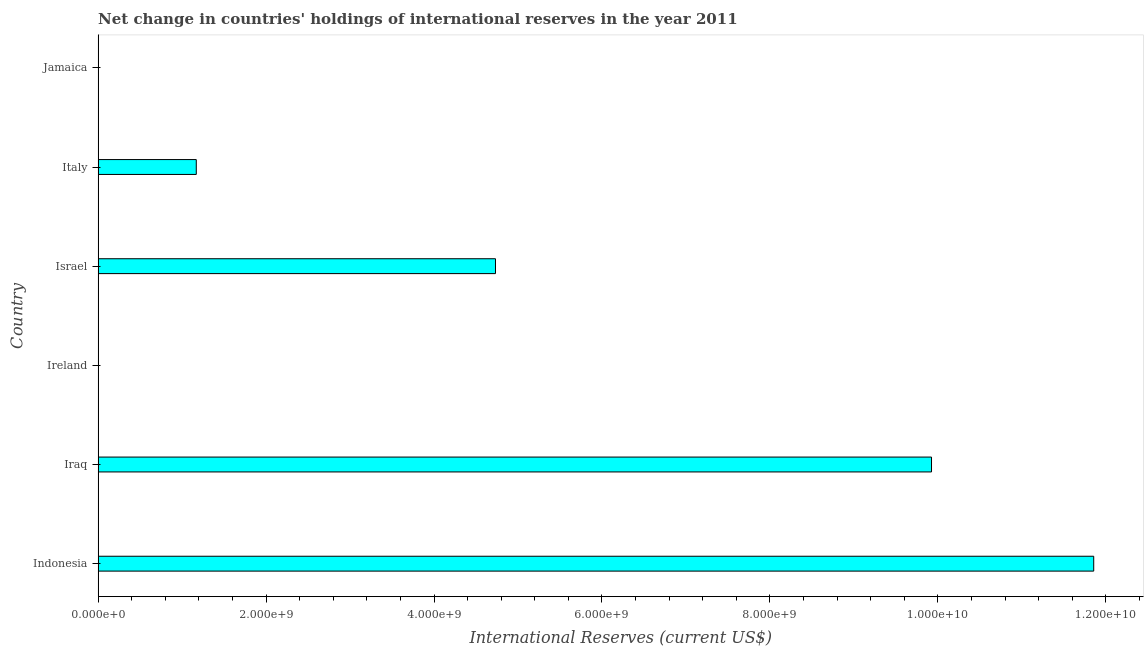Does the graph contain any zero values?
Make the answer very short. Yes. Does the graph contain grids?
Provide a succinct answer. No. What is the title of the graph?
Your answer should be very brief. Net change in countries' holdings of international reserves in the year 2011. What is the label or title of the X-axis?
Your answer should be very brief. International Reserves (current US$). What is the reserves and related items in Israel?
Your response must be concise. 4.73e+09. Across all countries, what is the maximum reserves and related items?
Provide a short and direct response. 1.19e+1. Across all countries, what is the minimum reserves and related items?
Your response must be concise. 0. In which country was the reserves and related items maximum?
Your answer should be very brief. Indonesia. What is the sum of the reserves and related items?
Your answer should be compact. 2.77e+1. What is the difference between the reserves and related items in Indonesia and Italy?
Make the answer very short. 1.07e+1. What is the average reserves and related items per country?
Offer a very short reply. 4.61e+09. What is the median reserves and related items?
Ensure brevity in your answer.  2.95e+09. What is the ratio of the reserves and related items in Indonesia to that in Italy?
Keep it short and to the point. 10.14. Is the reserves and related items in Iraq less than that in Israel?
Ensure brevity in your answer.  No. Is the difference between the reserves and related items in Iraq and Italy greater than the difference between any two countries?
Provide a short and direct response. No. What is the difference between the highest and the second highest reserves and related items?
Give a very brief answer. 1.93e+09. Is the sum of the reserves and related items in Indonesia and Israel greater than the maximum reserves and related items across all countries?
Ensure brevity in your answer.  Yes. What is the difference between the highest and the lowest reserves and related items?
Provide a succinct answer. 1.19e+1. Are all the bars in the graph horizontal?
Your answer should be very brief. Yes. How many countries are there in the graph?
Provide a short and direct response. 6. What is the difference between two consecutive major ticks on the X-axis?
Provide a succinct answer. 2.00e+09. Are the values on the major ticks of X-axis written in scientific E-notation?
Your answer should be compact. Yes. What is the International Reserves (current US$) in Indonesia?
Your answer should be very brief. 1.19e+1. What is the International Reserves (current US$) of Iraq?
Give a very brief answer. 9.92e+09. What is the International Reserves (current US$) in Ireland?
Your answer should be compact. 0. What is the International Reserves (current US$) in Israel?
Make the answer very short. 4.73e+09. What is the International Reserves (current US$) in Italy?
Make the answer very short. 1.17e+09. What is the International Reserves (current US$) in Jamaica?
Your answer should be compact. 0. What is the difference between the International Reserves (current US$) in Indonesia and Iraq?
Ensure brevity in your answer.  1.93e+09. What is the difference between the International Reserves (current US$) in Indonesia and Israel?
Offer a terse response. 7.12e+09. What is the difference between the International Reserves (current US$) in Indonesia and Italy?
Provide a succinct answer. 1.07e+1. What is the difference between the International Reserves (current US$) in Iraq and Israel?
Offer a very short reply. 5.19e+09. What is the difference between the International Reserves (current US$) in Iraq and Italy?
Give a very brief answer. 8.76e+09. What is the difference between the International Reserves (current US$) in Israel and Italy?
Your answer should be very brief. 3.56e+09. What is the ratio of the International Reserves (current US$) in Indonesia to that in Iraq?
Provide a short and direct response. 1.2. What is the ratio of the International Reserves (current US$) in Indonesia to that in Israel?
Provide a succinct answer. 2.5. What is the ratio of the International Reserves (current US$) in Indonesia to that in Italy?
Offer a terse response. 10.14. What is the ratio of the International Reserves (current US$) in Iraq to that in Israel?
Provide a succinct answer. 2.1. What is the ratio of the International Reserves (current US$) in Iraq to that in Italy?
Provide a short and direct response. 8.49. What is the ratio of the International Reserves (current US$) in Israel to that in Italy?
Your answer should be compact. 4.05. 